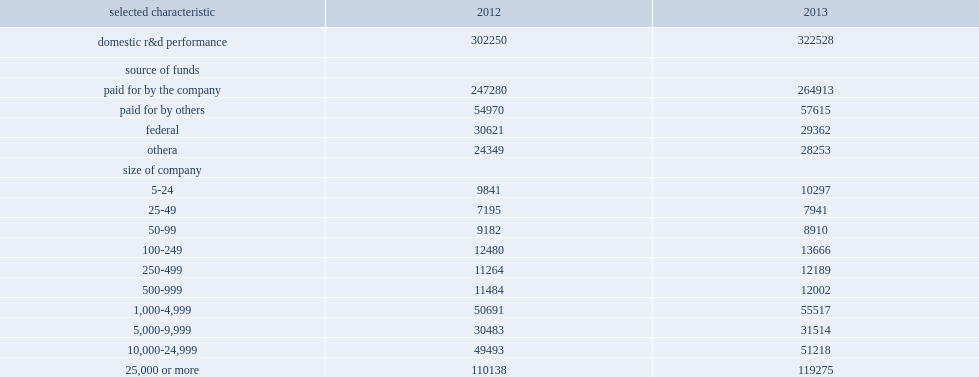How many million dollars did companies spend on research and development performed in the united states during 2013? 322528.0. How many million dollars did companies spend on research and development performed in the united states during 2012? 302250.0. Companies spent $323 billion on research and development performed in the united states during 2013, how many percent was more than the $302 billion spent during 2012? 0.06709. How many million dollars was funding from the companies' own sources during 2012? 247280.0. How many million dollars was funding from the companies' own sources during 2013? 264913.0. Funding from the companies' own sources was $247 billion during 2012 and $265 billion during 2013, how many percent of increase? 0.071308. How many million dollars was funding from other sources during 2012? 54970.0. How many million dollars was funding from other sources during 2013? 57615.0. 